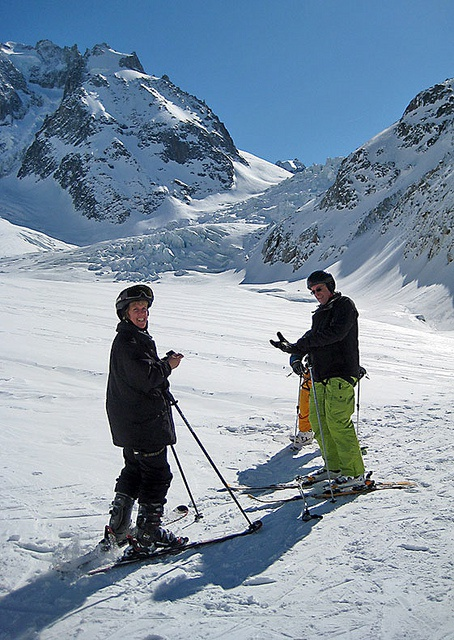Describe the objects in this image and their specific colors. I can see people in blue, black, darkgreen, and gray tones, skis in blue, black, gray, lightgray, and darkgray tones, skis in blue, black, gray, lightgray, and darkgray tones, people in blue, brown, darkgray, gray, and black tones, and skis in blue, gray, black, and darkgray tones in this image. 